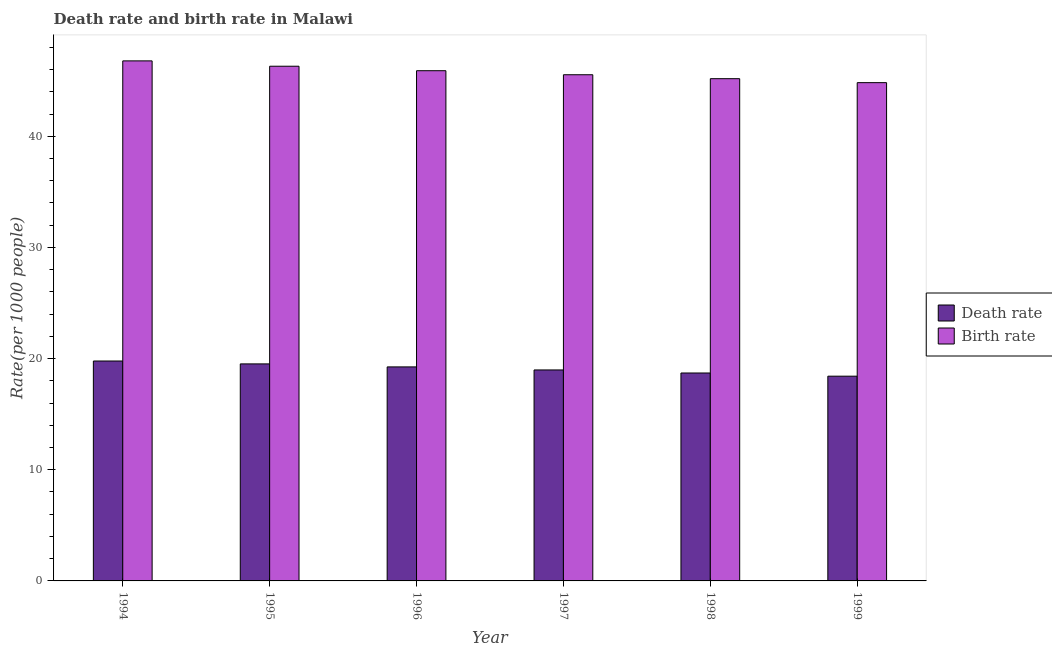How many groups of bars are there?
Provide a short and direct response. 6. What is the label of the 1st group of bars from the left?
Provide a succinct answer. 1994. What is the birth rate in 1995?
Your response must be concise. 46.3. Across all years, what is the maximum death rate?
Keep it short and to the point. 19.78. Across all years, what is the minimum death rate?
Offer a terse response. 18.42. In which year was the death rate maximum?
Provide a succinct answer. 1994. In which year was the birth rate minimum?
Your response must be concise. 1999. What is the total death rate in the graph?
Provide a succinct answer. 114.66. What is the difference between the birth rate in 1997 and that in 1999?
Ensure brevity in your answer.  0.71. What is the difference between the death rate in 1994 and the birth rate in 1999?
Your response must be concise. 1.37. What is the average death rate per year?
Give a very brief answer. 19.11. In how many years, is the death rate greater than 40?
Offer a very short reply. 0. What is the ratio of the birth rate in 1995 to that in 1997?
Your answer should be compact. 1.02. Is the death rate in 1994 less than that in 1995?
Ensure brevity in your answer.  No. What is the difference between the highest and the second highest birth rate?
Provide a short and direct response. 0.48. What is the difference between the highest and the lowest birth rate?
Make the answer very short. 1.96. Is the sum of the death rate in 1996 and 1998 greater than the maximum birth rate across all years?
Keep it short and to the point. Yes. What does the 1st bar from the left in 1994 represents?
Ensure brevity in your answer.  Death rate. What does the 1st bar from the right in 1995 represents?
Provide a short and direct response. Birth rate. How many years are there in the graph?
Give a very brief answer. 6. What is the difference between two consecutive major ticks on the Y-axis?
Offer a very short reply. 10. Are the values on the major ticks of Y-axis written in scientific E-notation?
Provide a short and direct response. No. Does the graph contain grids?
Your answer should be compact. No. Where does the legend appear in the graph?
Ensure brevity in your answer.  Center right. How many legend labels are there?
Your answer should be very brief. 2. How are the legend labels stacked?
Keep it short and to the point. Vertical. What is the title of the graph?
Keep it short and to the point. Death rate and birth rate in Malawi. Does "Resident" appear as one of the legend labels in the graph?
Keep it short and to the point. No. What is the label or title of the Y-axis?
Offer a terse response. Rate(per 1000 people). What is the Rate(per 1000 people) in Death rate in 1994?
Offer a very short reply. 19.78. What is the Rate(per 1000 people) in Birth rate in 1994?
Your answer should be compact. 46.78. What is the Rate(per 1000 people) in Death rate in 1995?
Offer a very short reply. 19.52. What is the Rate(per 1000 people) of Birth rate in 1995?
Provide a succinct answer. 46.3. What is the Rate(per 1000 people) of Death rate in 1996?
Your answer should be very brief. 19.25. What is the Rate(per 1000 people) in Birth rate in 1996?
Provide a short and direct response. 45.9. What is the Rate(per 1000 people) of Death rate in 1997?
Your response must be concise. 18.98. What is the Rate(per 1000 people) of Birth rate in 1997?
Ensure brevity in your answer.  45.54. What is the Rate(per 1000 people) of Death rate in 1998?
Give a very brief answer. 18.7. What is the Rate(per 1000 people) of Birth rate in 1998?
Your response must be concise. 45.18. What is the Rate(per 1000 people) of Death rate in 1999?
Make the answer very short. 18.42. What is the Rate(per 1000 people) in Birth rate in 1999?
Offer a terse response. 44.83. Across all years, what is the maximum Rate(per 1000 people) of Death rate?
Ensure brevity in your answer.  19.78. Across all years, what is the maximum Rate(per 1000 people) of Birth rate?
Ensure brevity in your answer.  46.78. Across all years, what is the minimum Rate(per 1000 people) of Death rate?
Offer a very short reply. 18.42. Across all years, what is the minimum Rate(per 1000 people) in Birth rate?
Offer a terse response. 44.83. What is the total Rate(per 1000 people) of Death rate in the graph?
Ensure brevity in your answer.  114.66. What is the total Rate(per 1000 people) of Birth rate in the graph?
Offer a terse response. 274.53. What is the difference between the Rate(per 1000 people) in Death rate in 1994 and that in 1995?
Ensure brevity in your answer.  0.26. What is the difference between the Rate(per 1000 people) of Birth rate in 1994 and that in 1995?
Give a very brief answer. 0.48. What is the difference between the Rate(per 1000 people) in Death rate in 1994 and that in 1996?
Your answer should be very brief. 0.53. What is the difference between the Rate(per 1000 people) of Birth rate in 1994 and that in 1996?
Give a very brief answer. 0.88. What is the difference between the Rate(per 1000 people) in Death rate in 1994 and that in 1997?
Provide a short and direct response. 0.8. What is the difference between the Rate(per 1000 people) in Birth rate in 1994 and that in 1997?
Keep it short and to the point. 1.25. What is the difference between the Rate(per 1000 people) in Death rate in 1994 and that in 1998?
Keep it short and to the point. 1.08. What is the difference between the Rate(per 1000 people) of Birth rate in 1994 and that in 1998?
Keep it short and to the point. 1.6. What is the difference between the Rate(per 1000 people) in Death rate in 1994 and that in 1999?
Offer a very short reply. 1.36. What is the difference between the Rate(per 1000 people) of Birth rate in 1994 and that in 1999?
Your response must be concise. 1.96. What is the difference between the Rate(per 1000 people) in Death rate in 1995 and that in 1996?
Offer a terse response. 0.27. What is the difference between the Rate(per 1000 people) of Birth rate in 1995 and that in 1996?
Provide a succinct answer. 0.4. What is the difference between the Rate(per 1000 people) in Death rate in 1995 and that in 1997?
Give a very brief answer. 0.54. What is the difference between the Rate(per 1000 people) in Birth rate in 1995 and that in 1997?
Offer a very short reply. 0.77. What is the difference between the Rate(per 1000 people) of Death rate in 1995 and that in 1998?
Offer a terse response. 0.82. What is the difference between the Rate(per 1000 people) of Birth rate in 1995 and that in 1998?
Offer a terse response. 1.12. What is the difference between the Rate(per 1000 people) of Death rate in 1995 and that in 1999?
Your response must be concise. 1.11. What is the difference between the Rate(per 1000 people) in Birth rate in 1995 and that in 1999?
Ensure brevity in your answer.  1.48. What is the difference between the Rate(per 1000 people) of Death rate in 1996 and that in 1997?
Your answer should be compact. 0.27. What is the difference between the Rate(per 1000 people) in Birth rate in 1996 and that in 1997?
Provide a short and direct response. 0.36. What is the difference between the Rate(per 1000 people) in Death rate in 1996 and that in 1998?
Offer a very short reply. 0.55. What is the difference between the Rate(per 1000 people) of Birth rate in 1996 and that in 1998?
Offer a very short reply. 0.72. What is the difference between the Rate(per 1000 people) of Death rate in 1996 and that in 1999?
Make the answer very short. 0.83. What is the difference between the Rate(per 1000 people) in Birth rate in 1996 and that in 1999?
Make the answer very short. 1.07. What is the difference between the Rate(per 1000 people) of Death rate in 1997 and that in 1998?
Ensure brevity in your answer.  0.28. What is the difference between the Rate(per 1000 people) of Birth rate in 1997 and that in 1998?
Your response must be concise. 0.35. What is the difference between the Rate(per 1000 people) in Death rate in 1997 and that in 1999?
Your answer should be compact. 0.56. What is the difference between the Rate(per 1000 people) in Birth rate in 1997 and that in 1999?
Offer a terse response. 0.71. What is the difference between the Rate(per 1000 people) in Death rate in 1998 and that in 1999?
Your response must be concise. 0.29. What is the difference between the Rate(per 1000 people) of Birth rate in 1998 and that in 1999?
Your answer should be compact. 0.36. What is the difference between the Rate(per 1000 people) of Death rate in 1994 and the Rate(per 1000 people) of Birth rate in 1995?
Keep it short and to the point. -26.52. What is the difference between the Rate(per 1000 people) of Death rate in 1994 and the Rate(per 1000 people) of Birth rate in 1996?
Make the answer very short. -26.12. What is the difference between the Rate(per 1000 people) of Death rate in 1994 and the Rate(per 1000 people) of Birth rate in 1997?
Make the answer very short. -25.75. What is the difference between the Rate(per 1000 people) of Death rate in 1994 and the Rate(per 1000 people) of Birth rate in 1998?
Your response must be concise. -25.4. What is the difference between the Rate(per 1000 people) in Death rate in 1994 and the Rate(per 1000 people) in Birth rate in 1999?
Provide a short and direct response. -25.04. What is the difference between the Rate(per 1000 people) in Death rate in 1995 and the Rate(per 1000 people) in Birth rate in 1996?
Offer a very short reply. -26.38. What is the difference between the Rate(per 1000 people) of Death rate in 1995 and the Rate(per 1000 people) of Birth rate in 1997?
Offer a very short reply. -26.01. What is the difference between the Rate(per 1000 people) of Death rate in 1995 and the Rate(per 1000 people) of Birth rate in 1998?
Make the answer very short. -25.66. What is the difference between the Rate(per 1000 people) of Death rate in 1995 and the Rate(per 1000 people) of Birth rate in 1999?
Ensure brevity in your answer.  -25.3. What is the difference between the Rate(per 1000 people) of Death rate in 1996 and the Rate(per 1000 people) of Birth rate in 1997?
Offer a very short reply. -26.28. What is the difference between the Rate(per 1000 people) in Death rate in 1996 and the Rate(per 1000 people) in Birth rate in 1998?
Give a very brief answer. -25.93. What is the difference between the Rate(per 1000 people) of Death rate in 1996 and the Rate(per 1000 people) of Birth rate in 1999?
Your answer should be compact. -25.57. What is the difference between the Rate(per 1000 people) of Death rate in 1997 and the Rate(per 1000 people) of Birth rate in 1998?
Provide a short and direct response. -26.2. What is the difference between the Rate(per 1000 people) in Death rate in 1997 and the Rate(per 1000 people) in Birth rate in 1999?
Give a very brief answer. -25.84. What is the difference between the Rate(per 1000 people) of Death rate in 1998 and the Rate(per 1000 people) of Birth rate in 1999?
Keep it short and to the point. -26.12. What is the average Rate(per 1000 people) of Death rate per year?
Offer a terse response. 19.11. What is the average Rate(per 1000 people) in Birth rate per year?
Offer a terse response. 45.75. In the year 1994, what is the difference between the Rate(per 1000 people) of Death rate and Rate(per 1000 people) of Birth rate?
Offer a very short reply. -27. In the year 1995, what is the difference between the Rate(per 1000 people) of Death rate and Rate(per 1000 people) of Birth rate?
Offer a very short reply. -26.78. In the year 1996, what is the difference between the Rate(per 1000 people) of Death rate and Rate(per 1000 people) of Birth rate?
Offer a terse response. -26.65. In the year 1997, what is the difference between the Rate(per 1000 people) of Death rate and Rate(per 1000 people) of Birth rate?
Offer a very short reply. -26.56. In the year 1998, what is the difference between the Rate(per 1000 people) of Death rate and Rate(per 1000 people) of Birth rate?
Your response must be concise. -26.48. In the year 1999, what is the difference between the Rate(per 1000 people) of Death rate and Rate(per 1000 people) of Birth rate?
Your answer should be compact. -26.41. What is the ratio of the Rate(per 1000 people) of Death rate in 1994 to that in 1995?
Offer a very short reply. 1.01. What is the ratio of the Rate(per 1000 people) of Birth rate in 1994 to that in 1995?
Your answer should be very brief. 1.01. What is the ratio of the Rate(per 1000 people) in Death rate in 1994 to that in 1996?
Give a very brief answer. 1.03. What is the ratio of the Rate(per 1000 people) in Birth rate in 1994 to that in 1996?
Your response must be concise. 1.02. What is the ratio of the Rate(per 1000 people) in Death rate in 1994 to that in 1997?
Your answer should be compact. 1.04. What is the ratio of the Rate(per 1000 people) in Birth rate in 1994 to that in 1997?
Keep it short and to the point. 1.03. What is the ratio of the Rate(per 1000 people) in Death rate in 1994 to that in 1998?
Offer a very short reply. 1.06. What is the ratio of the Rate(per 1000 people) in Birth rate in 1994 to that in 1998?
Your response must be concise. 1.04. What is the ratio of the Rate(per 1000 people) in Death rate in 1994 to that in 1999?
Ensure brevity in your answer.  1.07. What is the ratio of the Rate(per 1000 people) in Birth rate in 1994 to that in 1999?
Offer a very short reply. 1.04. What is the ratio of the Rate(per 1000 people) in Death rate in 1995 to that in 1996?
Offer a terse response. 1.01. What is the ratio of the Rate(per 1000 people) in Birth rate in 1995 to that in 1996?
Provide a short and direct response. 1.01. What is the ratio of the Rate(per 1000 people) in Death rate in 1995 to that in 1997?
Ensure brevity in your answer.  1.03. What is the ratio of the Rate(per 1000 people) in Birth rate in 1995 to that in 1997?
Offer a very short reply. 1.02. What is the ratio of the Rate(per 1000 people) in Death rate in 1995 to that in 1998?
Offer a very short reply. 1.04. What is the ratio of the Rate(per 1000 people) of Birth rate in 1995 to that in 1998?
Provide a short and direct response. 1.02. What is the ratio of the Rate(per 1000 people) of Death rate in 1995 to that in 1999?
Provide a short and direct response. 1.06. What is the ratio of the Rate(per 1000 people) in Birth rate in 1995 to that in 1999?
Your response must be concise. 1.03. What is the ratio of the Rate(per 1000 people) of Death rate in 1996 to that in 1997?
Your answer should be compact. 1.01. What is the ratio of the Rate(per 1000 people) of Birth rate in 1996 to that in 1997?
Offer a very short reply. 1.01. What is the ratio of the Rate(per 1000 people) in Death rate in 1996 to that in 1998?
Your answer should be compact. 1.03. What is the ratio of the Rate(per 1000 people) of Birth rate in 1996 to that in 1998?
Make the answer very short. 1.02. What is the ratio of the Rate(per 1000 people) of Death rate in 1996 to that in 1999?
Provide a succinct answer. 1.05. What is the ratio of the Rate(per 1000 people) of Death rate in 1997 to that in 1998?
Offer a very short reply. 1.01. What is the ratio of the Rate(per 1000 people) of Birth rate in 1997 to that in 1998?
Your answer should be compact. 1.01. What is the ratio of the Rate(per 1000 people) in Death rate in 1997 to that in 1999?
Offer a terse response. 1.03. What is the ratio of the Rate(per 1000 people) of Birth rate in 1997 to that in 1999?
Offer a terse response. 1.02. What is the ratio of the Rate(per 1000 people) of Death rate in 1998 to that in 1999?
Keep it short and to the point. 1.02. What is the ratio of the Rate(per 1000 people) of Birth rate in 1998 to that in 1999?
Your answer should be very brief. 1.01. What is the difference between the highest and the second highest Rate(per 1000 people) of Death rate?
Make the answer very short. 0.26. What is the difference between the highest and the second highest Rate(per 1000 people) in Birth rate?
Make the answer very short. 0.48. What is the difference between the highest and the lowest Rate(per 1000 people) in Death rate?
Offer a very short reply. 1.36. What is the difference between the highest and the lowest Rate(per 1000 people) of Birth rate?
Make the answer very short. 1.96. 